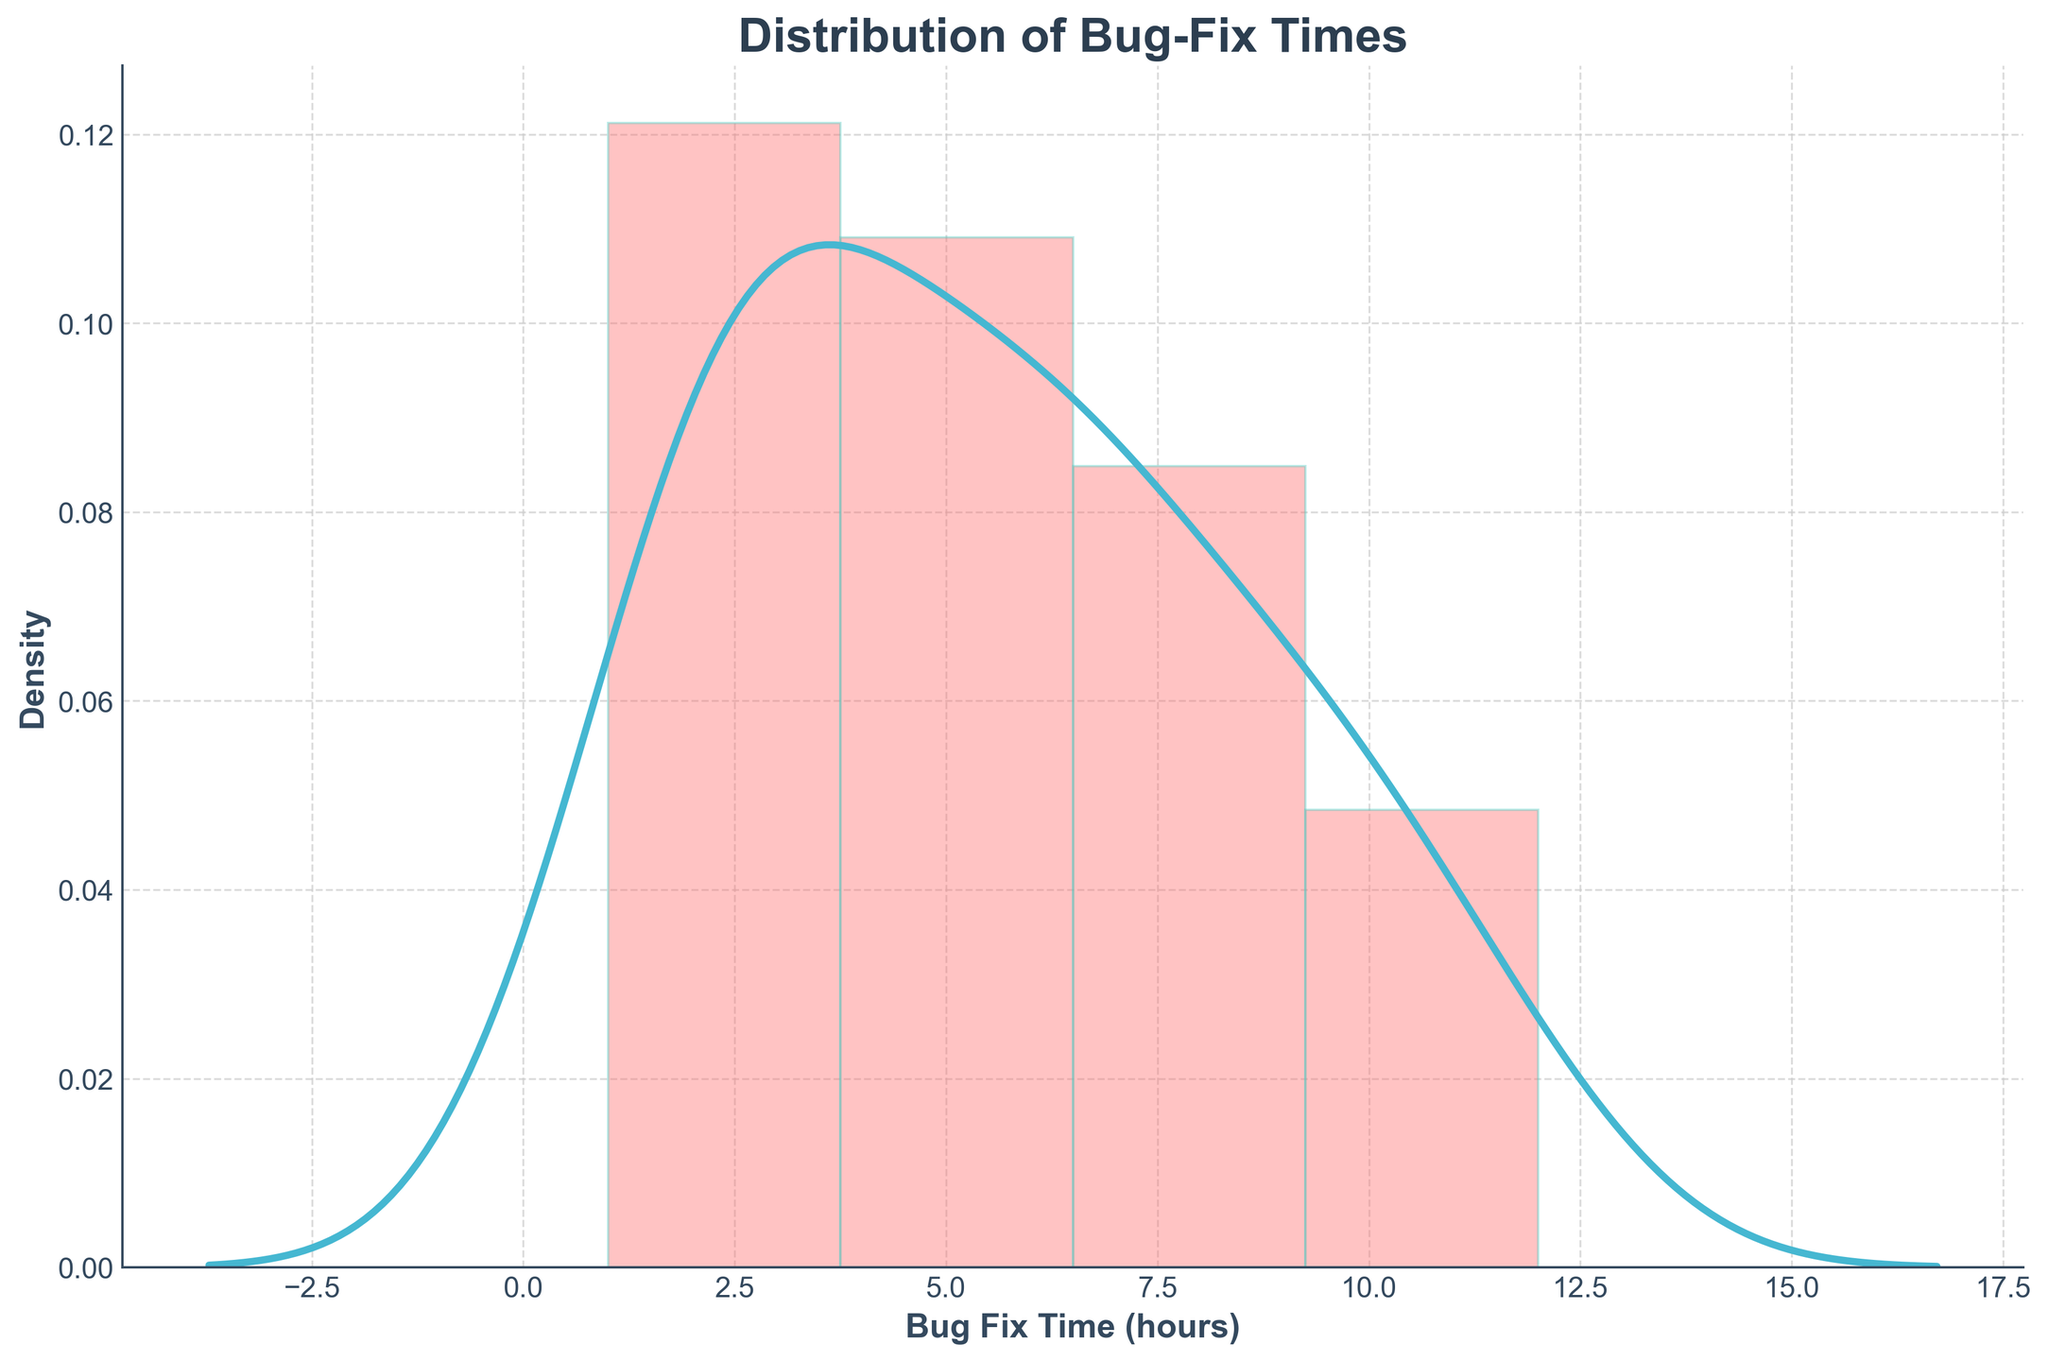What is the title of the plot? The plot's title is located at the top of the figure. It reflects the main subject or data being visualized.
Answer: Distribution of Bug-Fix Times What does the x-axis represent? The x-axis label describes the data being measured on this axis. It is usually located below the axis.
Answer: Bug Fix Time (hours) What does the y-axis represent? The y-axis label describes the data being measured on this axis. It is typically located to the left of the axis.
Answer: Density What is the range of Bug Fix Times shown on the x-axis? By examining the x-axis, you can see the minimum and maximum values displayed.
Answer: 0 to around 12 hours Is the mode of the Bug Fix Times below 3 hours? The mode is indicated by the peak of the distribution curve. Since the highest peak is around 2 hours, we can confirm this.
Answer: Yes Are there more bug fix times concentrated around lower hours or higher hours? The concentration can be observed by looking at where the density is higher. In this case, the density is higher towards the left of the plot, indicating lower hours.
Answer: Lower hours How would you describe the overall shape of the distribution curve? By looking at the plot, note if it's unimodal, bimodal, symmetric, skewed, etc. Here, the curve has one noticeable peak, indicating that it is unimodal and right-skewed.
Answer: Unimodal and right-skewed What can you infer from the length of the tail on the right side of the plot? The extended tail on the right side signifies that there are some bug-fix times that are significantly longer than most others.
Answer: There are some longer bug-fix times Does the plot suggest that bug fixes most often take a very short time, a moderate time, or a long time? The density of the plot is highest at the lower values of bug-fix times. This suggests that most bug fixes are resolved quickly.
Answer: A very short time How smooth is the KDE (Kernel Density Estimate) curve? The KDE curve can be evaluated for smoothness by observing the transitions and peaks throughout the distribution. Here, it appears smooth with a single prominent peak and a long tail.
Answer: Smooth 